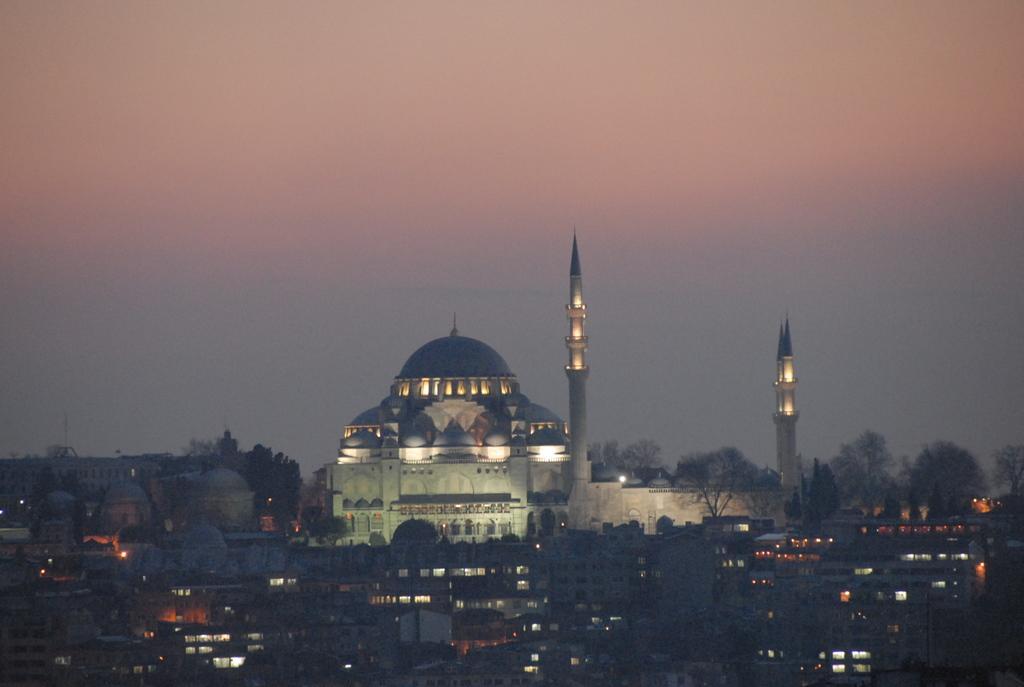Can you describe this image briefly? In this image I can see few buildings, in front the building is in white color and I can see few lights. Background I can see the sky. 